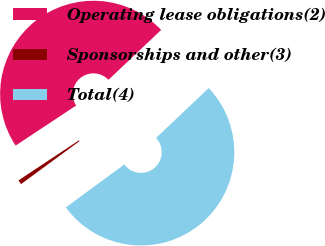Convert chart to OTSL. <chart><loc_0><loc_0><loc_500><loc_500><pie_chart><fcel>Operating lease obligations(2)<fcel>Sponsorships and other(3)<fcel>Total(4)<nl><fcel>47.25%<fcel>0.77%<fcel>51.98%<nl></chart> 